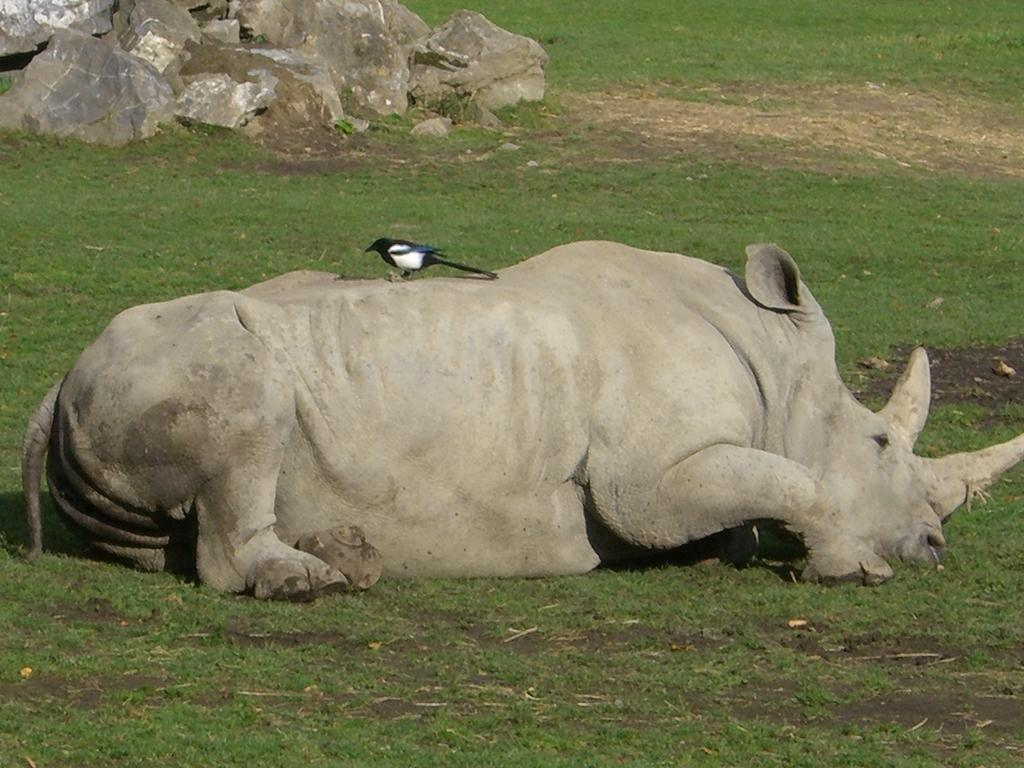What animal is the main subject of the image? There is a rhinoceros in the image. What is the rhinoceros doing in the image? The rhinoceros is laying on the grass. Is there any other animal present in the image? Yes, there is a small bird standing on the rhinoceros. What can be seen in the background of the image? There are many rocks visible behind the rhinoceros. What type of sweater is the rhinoceros wearing in the image? The rhinoceros is not wearing a sweater in the image; it is laying on the grass with a small bird standing on it. 